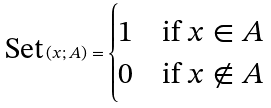<formula> <loc_0><loc_0><loc_500><loc_500>\text {Set} \left ( x ; A \right ) = { \begin{cases} \text  1&{\text {if }} x \in A \\ 0 & { \text {if } } x \notin A \end{cases} }</formula> 